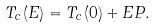Convert formula to latex. <formula><loc_0><loc_0><loc_500><loc_500>T _ { c } ( E ) = T _ { c } ( 0 ) + E P .</formula> 